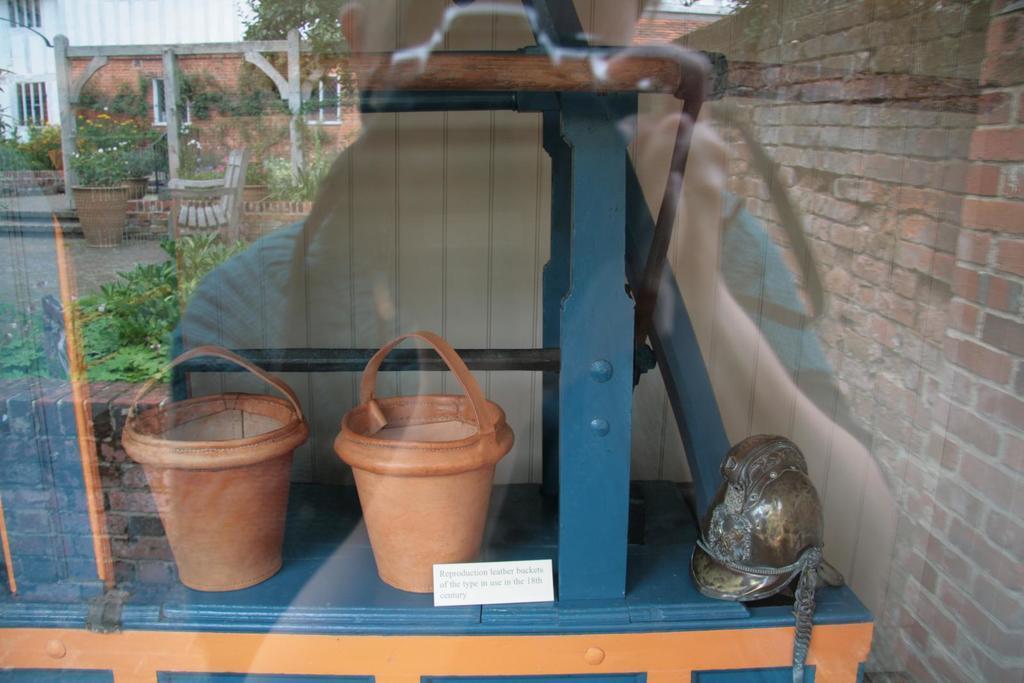Can you describe this image briefly? In this image there are two pots and an object are on the table which are behind the glass. On glass there is a reflection of the person holding a camera in his hand. Behind him there is a wall. There are few plants, chair and few pots with plants. Behind there is a building and a tree. 